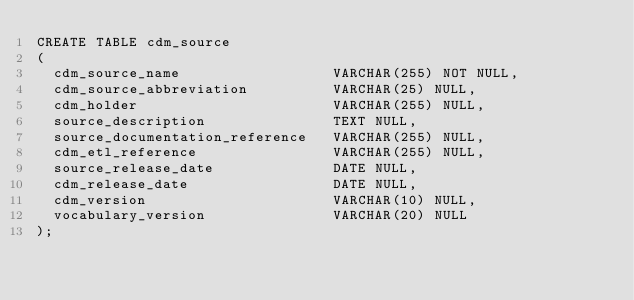<code> <loc_0><loc_0><loc_500><loc_500><_SQL_>CREATE TABLE cdm_source
(
  cdm_source_name                  VARCHAR(255) NOT NULL,
  cdm_source_abbreviation          VARCHAR(25) NULL,
  cdm_holder                       VARCHAR(255) NULL,
  source_description               TEXT NULL,
  source_documentation_reference   VARCHAR(255) NULL,
  cdm_etl_reference                VARCHAR(255) NULL,
  source_release_date              DATE NULL,
  cdm_release_date                 DATE NULL,
  cdm_version                      VARCHAR(10) NULL,
  vocabulary_version               VARCHAR(20) NULL
);
</code> 